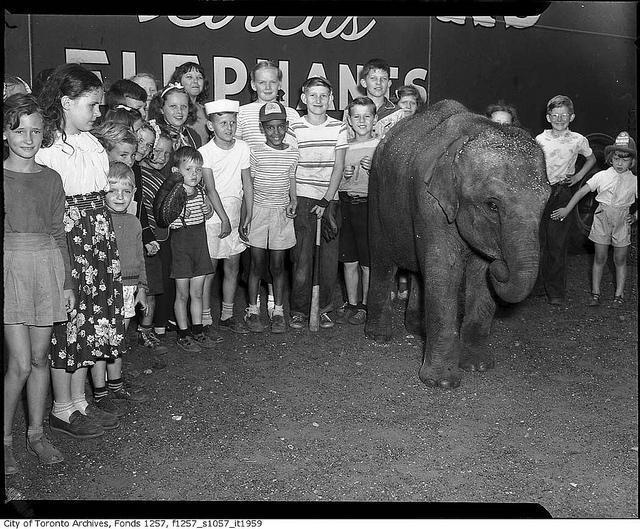How many animals are in the picture?
Give a very brief answer. 1. How many people are in the picture?
Give a very brief answer. 13. How many white trucks are there in the image ?
Give a very brief answer. 0. 